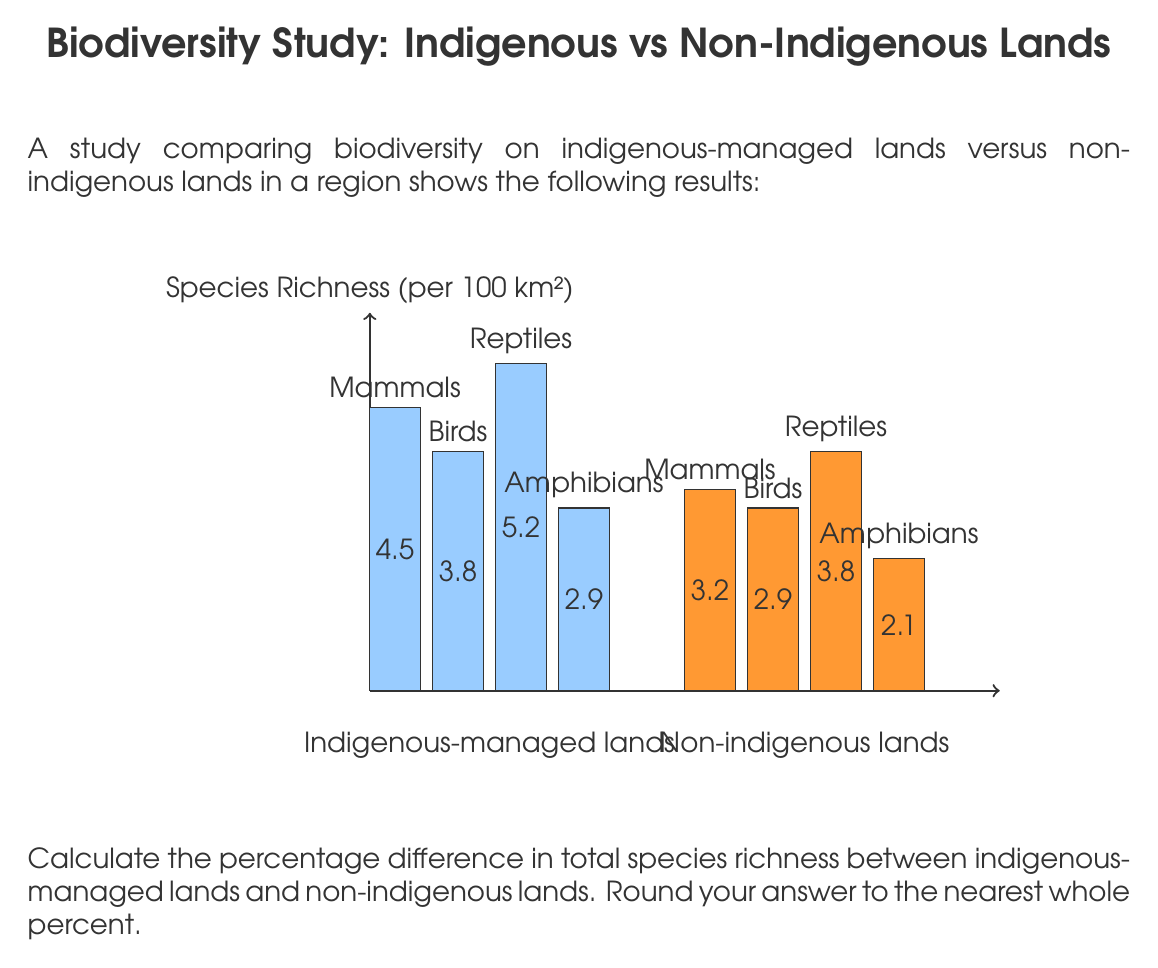Teach me how to tackle this problem. 1. Calculate the total species richness for indigenous-managed lands:
   $4.5 + 3.8 + 5.2 + 2.9 = 16.4$ species per 100 km²

2. Calculate the total species richness for non-indigenous lands:
   $3.2 + 2.9 + 3.8 + 2.1 = 12.0$ species per 100 km²

3. Calculate the difference in species richness:
   $16.4 - 12.0 = 4.4$ species per 100 km²

4. Calculate the percentage difference:
   Percentage difference = $\frac{\text{Difference}}{\text{Value of non-indigenous lands}} \times 100\%$
   $= \frac{4.4}{12.0} \times 100\% = 36.67\%$

5. Round to the nearest whole percent:
   $36.67\% \approx 37\%$
Answer: 37% 